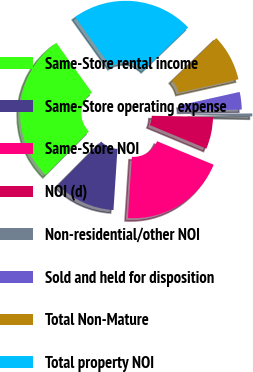Convert chart to OTSL. <chart><loc_0><loc_0><loc_500><loc_500><pie_chart><fcel>Same-Store rental income<fcel>Same-Store operating expense<fcel>Same-Store NOI<fcel>NOI (d)<fcel>Non-residential/other NOI<fcel>Sold and held for disposition<fcel>Total Non-Mature<fcel>Total property NOI<nl><fcel>27.67%<fcel>11.4%<fcel>19.76%<fcel>5.97%<fcel>0.55%<fcel>3.26%<fcel>8.68%<fcel>22.71%<nl></chart> 